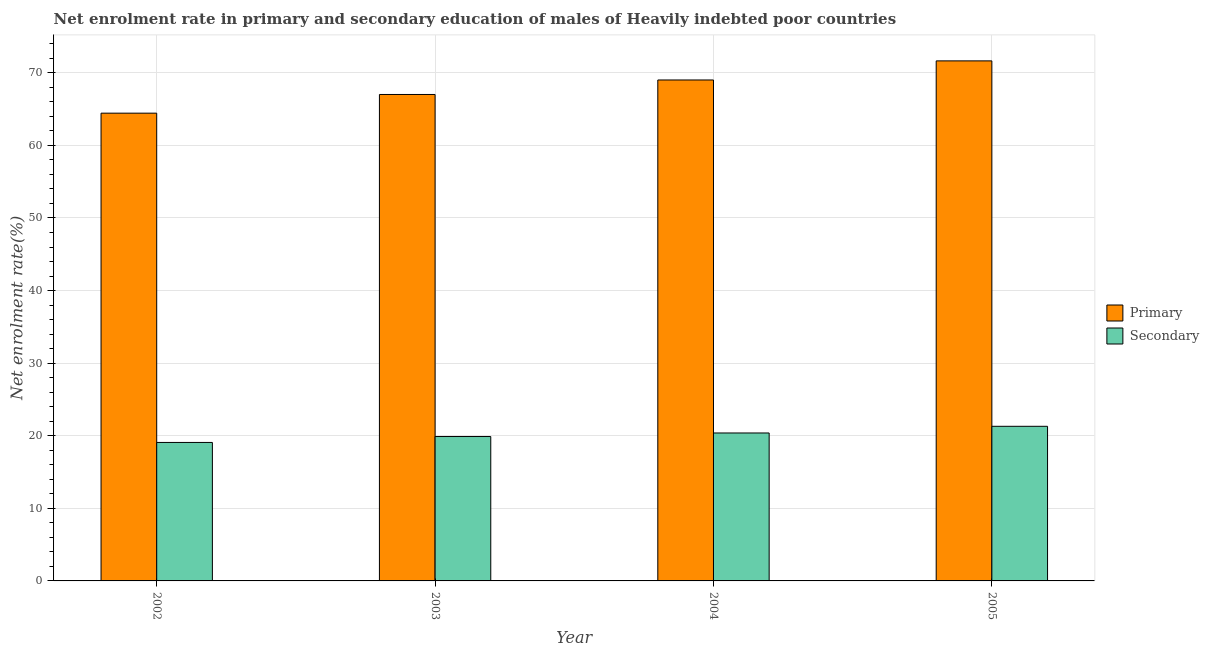How many different coloured bars are there?
Give a very brief answer. 2. Are the number of bars per tick equal to the number of legend labels?
Your answer should be very brief. Yes. How many bars are there on the 2nd tick from the left?
Give a very brief answer. 2. What is the label of the 3rd group of bars from the left?
Make the answer very short. 2004. In how many cases, is the number of bars for a given year not equal to the number of legend labels?
Give a very brief answer. 0. What is the enrollment rate in secondary education in 2002?
Your response must be concise. 19.08. Across all years, what is the maximum enrollment rate in secondary education?
Provide a succinct answer. 21.3. Across all years, what is the minimum enrollment rate in primary education?
Offer a very short reply. 64.44. In which year was the enrollment rate in secondary education maximum?
Make the answer very short. 2005. In which year was the enrollment rate in secondary education minimum?
Provide a short and direct response. 2002. What is the total enrollment rate in secondary education in the graph?
Give a very brief answer. 80.65. What is the difference between the enrollment rate in secondary education in 2002 and that in 2004?
Keep it short and to the point. -1.3. What is the difference between the enrollment rate in primary education in 2005 and the enrollment rate in secondary education in 2004?
Your answer should be very brief. 2.63. What is the average enrollment rate in primary education per year?
Offer a very short reply. 68.02. What is the ratio of the enrollment rate in primary education in 2004 to that in 2005?
Keep it short and to the point. 0.96. What is the difference between the highest and the second highest enrollment rate in primary education?
Make the answer very short. 2.63. What is the difference between the highest and the lowest enrollment rate in primary education?
Offer a very short reply. 7.2. Is the sum of the enrollment rate in secondary education in 2002 and 2005 greater than the maximum enrollment rate in primary education across all years?
Provide a short and direct response. Yes. What does the 2nd bar from the left in 2002 represents?
Offer a terse response. Secondary. What does the 2nd bar from the right in 2002 represents?
Your answer should be compact. Primary. How many bars are there?
Keep it short and to the point. 8. Are all the bars in the graph horizontal?
Provide a short and direct response. No. How many years are there in the graph?
Provide a succinct answer. 4. Are the values on the major ticks of Y-axis written in scientific E-notation?
Your answer should be very brief. No. Does the graph contain any zero values?
Make the answer very short. No. How are the legend labels stacked?
Provide a short and direct response. Vertical. What is the title of the graph?
Provide a succinct answer. Net enrolment rate in primary and secondary education of males of Heavily indebted poor countries. Does "Domestic liabilities" appear as one of the legend labels in the graph?
Keep it short and to the point. No. What is the label or title of the X-axis?
Provide a succinct answer. Year. What is the label or title of the Y-axis?
Keep it short and to the point. Net enrolment rate(%). What is the Net enrolment rate(%) of Primary in 2002?
Your answer should be compact. 64.44. What is the Net enrolment rate(%) of Secondary in 2002?
Offer a terse response. 19.08. What is the Net enrolment rate(%) in Primary in 2003?
Your answer should be very brief. 67.01. What is the Net enrolment rate(%) in Secondary in 2003?
Provide a short and direct response. 19.89. What is the Net enrolment rate(%) of Primary in 2004?
Keep it short and to the point. 69.01. What is the Net enrolment rate(%) in Secondary in 2004?
Keep it short and to the point. 20.38. What is the Net enrolment rate(%) of Primary in 2005?
Give a very brief answer. 71.64. What is the Net enrolment rate(%) in Secondary in 2005?
Offer a very short reply. 21.3. Across all years, what is the maximum Net enrolment rate(%) of Primary?
Ensure brevity in your answer.  71.64. Across all years, what is the maximum Net enrolment rate(%) of Secondary?
Your answer should be compact. 21.3. Across all years, what is the minimum Net enrolment rate(%) of Primary?
Your answer should be compact. 64.44. Across all years, what is the minimum Net enrolment rate(%) in Secondary?
Make the answer very short. 19.08. What is the total Net enrolment rate(%) in Primary in the graph?
Offer a terse response. 272.1. What is the total Net enrolment rate(%) in Secondary in the graph?
Your response must be concise. 80.65. What is the difference between the Net enrolment rate(%) in Primary in 2002 and that in 2003?
Your answer should be very brief. -2.57. What is the difference between the Net enrolment rate(%) in Secondary in 2002 and that in 2003?
Your answer should be compact. -0.82. What is the difference between the Net enrolment rate(%) of Primary in 2002 and that in 2004?
Ensure brevity in your answer.  -4.57. What is the difference between the Net enrolment rate(%) of Secondary in 2002 and that in 2004?
Provide a succinct answer. -1.3. What is the difference between the Net enrolment rate(%) in Primary in 2002 and that in 2005?
Your answer should be compact. -7.2. What is the difference between the Net enrolment rate(%) of Secondary in 2002 and that in 2005?
Provide a short and direct response. -2.22. What is the difference between the Net enrolment rate(%) of Primary in 2003 and that in 2004?
Provide a short and direct response. -2. What is the difference between the Net enrolment rate(%) in Secondary in 2003 and that in 2004?
Offer a very short reply. -0.49. What is the difference between the Net enrolment rate(%) of Primary in 2003 and that in 2005?
Offer a terse response. -4.63. What is the difference between the Net enrolment rate(%) in Secondary in 2003 and that in 2005?
Your answer should be compact. -1.41. What is the difference between the Net enrolment rate(%) in Primary in 2004 and that in 2005?
Provide a short and direct response. -2.63. What is the difference between the Net enrolment rate(%) in Secondary in 2004 and that in 2005?
Provide a short and direct response. -0.92. What is the difference between the Net enrolment rate(%) in Primary in 2002 and the Net enrolment rate(%) in Secondary in 2003?
Offer a very short reply. 44.54. What is the difference between the Net enrolment rate(%) in Primary in 2002 and the Net enrolment rate(%) in Secondary in 2004?
Your response must be concise. 44.06. What is the difference between the Net enrolment rate(%) of Primary in 2002 and the Net enrolment rate(%) of Secondary in 2005?
Give a very brief answer. 43.14. What is the difference between the Net enrolment rate(%) in Primary in 2003 and the Net enrolment rate(%) in Secondary in 2004?
Your answer should be compact. 46.63. What is the difference between the Net enrolment rate(%) in Primary in 2003 and the Net enrolment rate(%) in Secondary in 2005?
Your answer should be compact. 45.71. What is the difference between the Net enrolment rate(%) of Primary in 2004 and the Net enrolment rate(%) of Secondary in 2005?
Make the answer very short. 47.71. What is the average Net enrolment rate(%) in Primary per year?
Offer a terse response. 68.03. What is the average Net enrolment rate(%) of Secondary per year?
Keep it short and to the point. 20.16. In the year 2002, what is the difference between the Net enrolment rate(%) of Primary and Net enrolment rate(%) of Secondary?
Offer a very short reply. 45.36. In the year 2003, what is the difference between the Net enrolment rate(%) in Primary and Net enrolment rate(%) in Secondary?
Offer a terse response. 47.12. In the year 2004, what is the difference between the Net enrolment rate(%) in Primary and Net enrolment rate(%) in Secondary?
Offer a terse response. 48.63. In the year 2005, what is the difference between the Net enrolment rate(%) in Primary and Net enrolment rate(%) in Secondary?
Your answer should be compact. 50.34. What is the ratio of the Net enrolment rate(%) in Primary in 2002 to that in 2003?
Keep it short and to the point. 0.96. What is the ratio of the Net enrolment rate(%) in Secondary in 2002 to that in 2003?
Offer a terse response. 0.96. What is the ratio of the Net enrolment rate(%) of Primary in 2002 to that in 2004?
Your answer should be compact. 0.93. What is the ratio of the Net enrolment rate(%) in Secondary in 2002 to that in 2004?
Give a very brief answer. 0.94. What is the ratio of the Net enrolment rate(%) of Primary in 2002 to that in 2005?
Your answer should be very brief. 0.9. What is the ratio of the Net enrolment rate(%) in Secondary in 2002 to that in 2005?
Your response must be concise. 0.9. What is the ratio of the Net enrolment rate(%) of Primary in 2003 to that in 2004?
Your response must be concise. 0.97. What is the ratio of the Net enrolment rate(%) in Secondary in 2003 to that in 2004?
Give a very brief answer. 0.98. What is the ratio of the Net enrolment rate(%) of Primary in 2003 to that in 2005?
Give a very brief answer. 0.94. What is the ratio of the Net enrolment rate(%) of Secondary in 2003 to that in 2005?
Offer a very short reply. 0.93. What is the ratio of the Net enrolment rate(%) in Primary in 2004 to that in 2005?
Your answer should be compact. 0.96. What is the ratio of the Net enrolment rate(%) in Secondary in 2004 to that in 2005?
Your response must be concise. 0.96. What is the difference between the highest and the second highest Net enrolment rate(%) of Primary?
Provide a short and direct response. 2.63. What is the difference between the highest and the second highest Net enrolment rate(%) in Secondary?
Your answer should be compact. 0.92. What is the difference between the highest and the lowest Net enrolment rate(%) of Primary?
Offer a very short reply. 7.2. What is the difference between the highest and the lowest Net enrolment rate(%) in Secondary?
Offer a very short reply. 2.22. 